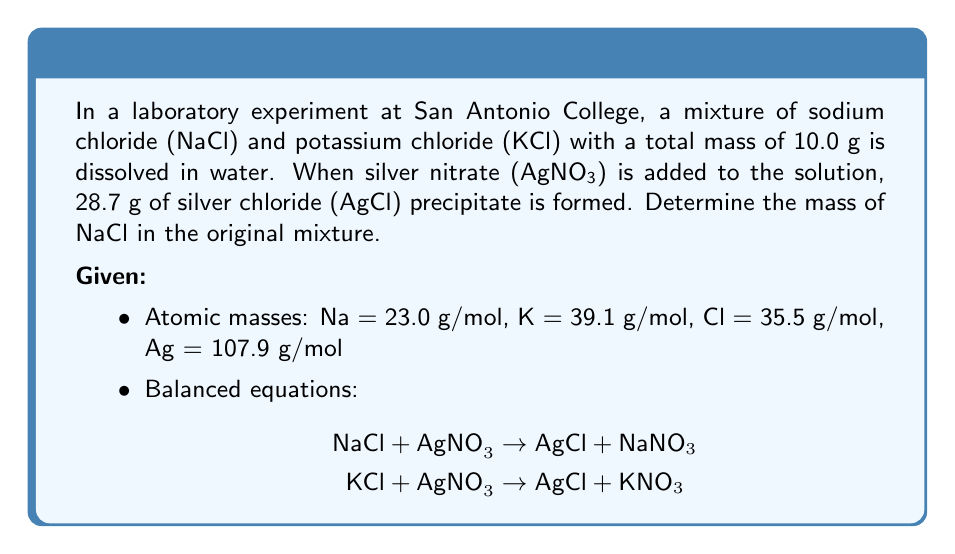Teach me how to tackle this problem. Let's approach this problem step-by-step:

1) First, let's define variables:
   Let $x$ = mass of NaCl in grams
   Then, $(10.0 - x)$ = mass of KCl in grams

2) Calculate the number of moles of AgCl formed:
   $$\text{Moles of AgCl} = \frac{28.7 \text{ g}}{(107.9 + 35.5) \text{ g/mol}} = 0.2 \text{ mol}$$

3) The number of moles of AgCl is equal to the total number of moles of Cl⁻ ions from both NaCl and KCl:
   $$0.2 = \frac{x}{58.5} + \frac{10.0 - x}{74.6}$$
   Where 58.5 g/mol is the molar mass of NaCl and 74.6 g/mol is the molar mass of KCl.

4) Multiply both sides by 58.5 × 74.6:
   $$871.8 = 74.6x + 58.5(10.0 - x)$$

5) Simplify:
   $$871.8 = 74.6x + 585 - 58.5x$$
   $$871.8 = 16.1x + 585$$

6) Subtract 585 from both sides:
   $$286.8 = 16.1x$$

7) Divide both sides by 16.1:
   $$x = 17.8 \text{ g}$$

Therefore, the mass of NaCl in the original mixture is 17.8 g.
Answer: 17.8 g 